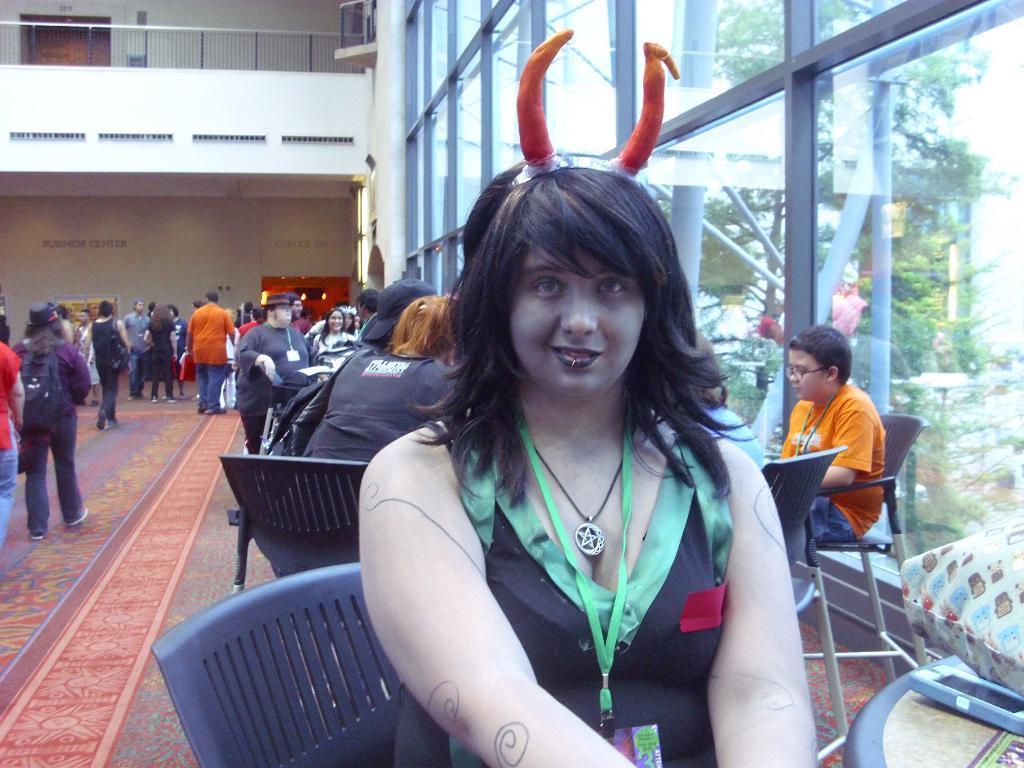Describe this image in one or two sentences. In the picture we can see a woman sitting on the chair, she is in a costume and behind her we can see some people are sitting near the tables and beside them, we can see a glass wall and opposite side, we can see some people are walking and in the background we can see a floor with a railing and behind it we can see a door. 